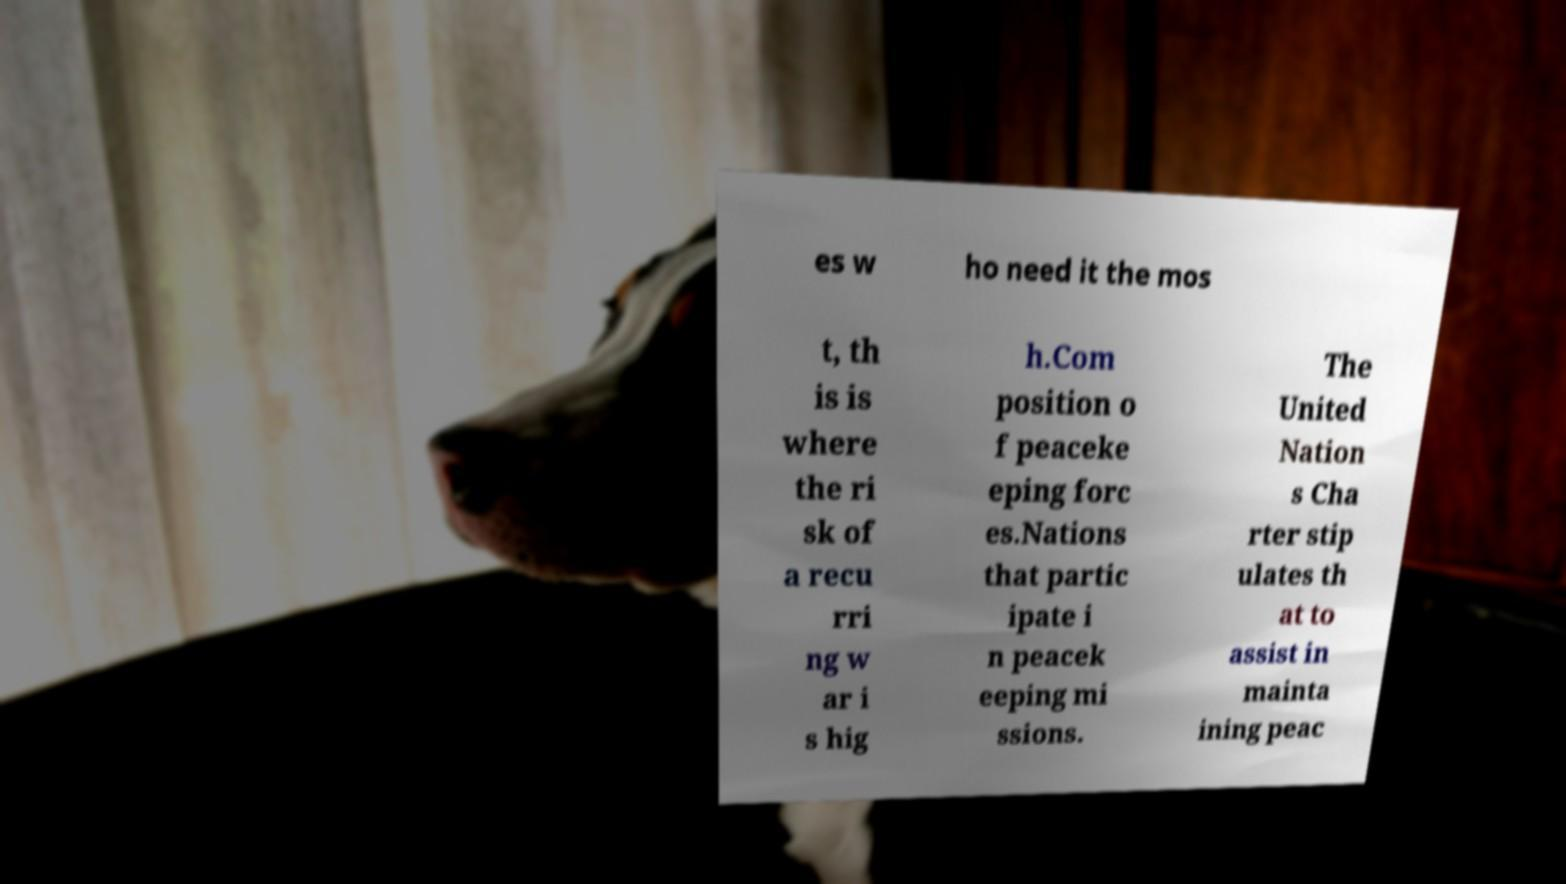Can you read and provide the text displayed in the image?This photo seems to have some interesting text. Can you extract and type it out for me? es w ho need it the mos t, th is is where the ri sk of a recu rri ng w ar i s hig h.Com position o f peaceke eping forc es.Nations that partic ipate i n peacek eeping mi ssions. The United Nation s Cha rter stip ulates th at to assist in mainta ining peac 